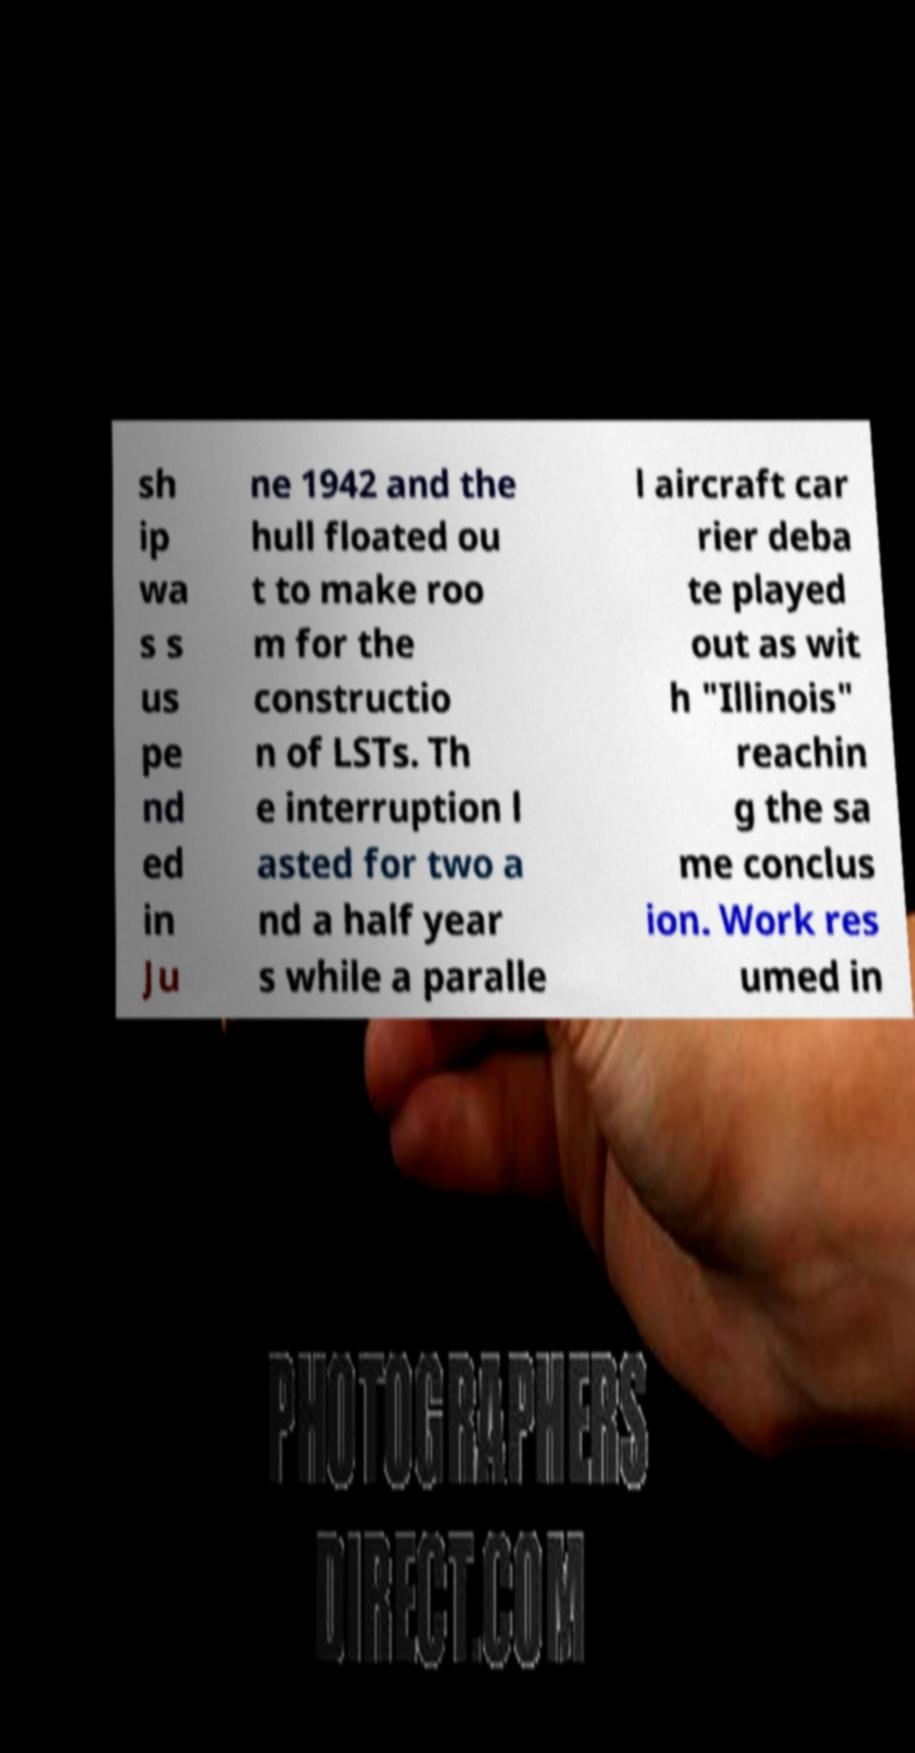I need the written content from this picture converted into text. Can you do that? sh ip wa s s us pe nd ed in Ju ne 1942 and the hull floated ou t to make roo m for the constructio n of LSTs. Th e interruption l asted for two a nd a half year s while a paralle l aircraft car rier deba te played out as wit h "Illinois" reachin g the sa me conclus ion. Work res umed in 